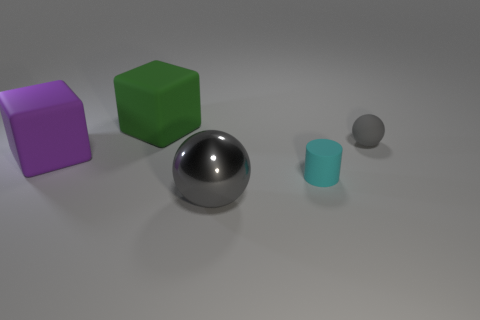Is the number of purple blocks greater than the number of gray balls?
Provide a succinct answer. No. Are there any other things of the same color as the small rubber cylinder?
Make the answer very short. No. There is a green thing that is made of the same material as the small cyan cylinder; what is its shape?
Provide a succinct answer. Cube. What material is the gray ball that is in front of the tiny rubber thing that is right of the tiny cylinder?
Your response must be concise. Metal. There is a gray object that is behind the gray shiny sphere; is it the same shape as the big gray thing?
Give a very brief answer. Yes. Are there more big blocks that are behind the big shiny ball than tiny gray matte balls?
Make the answer very short. Yes. Is there any other thing that has the same material as the big gray object?
Give a very brief answer. No. What is the shape of the large metallic object that is the same color as the matte sphere?
Make the answer very short. Sphere. How many balls are either small brown shiny things or tiny gray things?
Provide a succinct answer. 1. What color is the big cube that is behind the large cube in front of the big green block?
Your response must be concise. Green. 